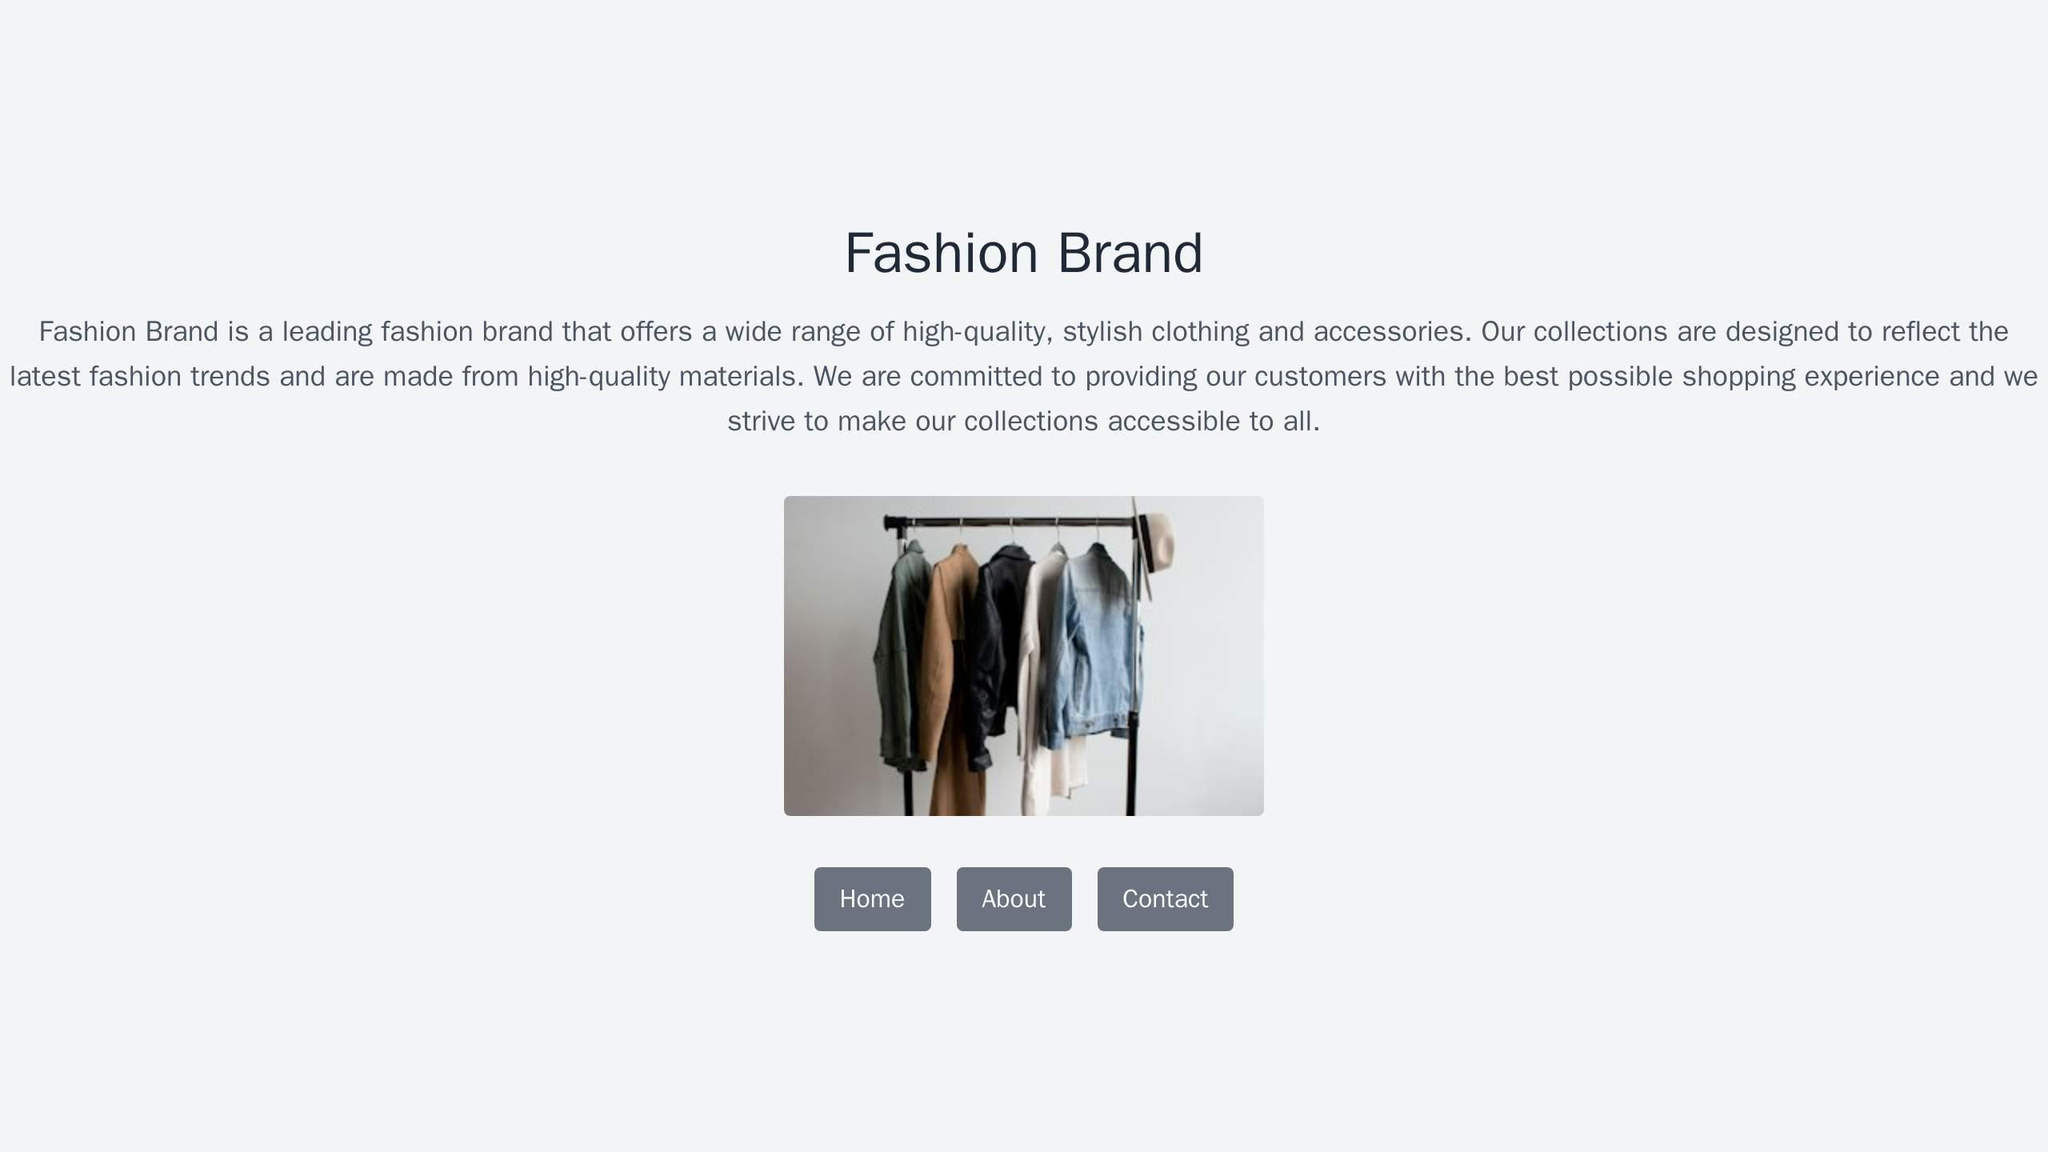\nYou are an expert Tailwind developer\nYou take screenshots of a reference web page from the user, and then build a single page apps\nusing Tailwind, HTML and JS.\n\n- Make sure the app looks exactly like the screenshot.\n- Pay close attention to background color, text color, font size, font family, \npadding, margin, border, etc. Match the colors and sizes exactly.\n- Use the exact text from the screenshot.\n- Do not add comments in the code such as \"<!-- Add other navigation links as needed -->\" and \"<!-- ... other news items ... -->\" in place of writing the full code. WRITE THE FULL CODE.\n- Repeat elements as needed to match the screenshot. For example, if there are 15 items, the code should have 15 items. DO NOT LEAVE comments like \"<!-- Repeat for each news item -->\" or bad things will happen.\n- For images, use placeholder images from https://placehold.co and include a detailed description of the image in the alt text so that an image generation AI can generate the image later.\n\nIn terms of libraries,\n\n- Use this script to include Tailwind: <script src=\"https://cdn.tailwindcss.com\"></script>\n\nReturn only the full code in <html></html> tags.\nDo not include markdown \"```\" or \"```html\" at the start or end.\n <html>
  <head>
    <title>Fashion Brand</title>
    <script src="https://cdn.tailwindcss.com"></script>
  </head>
  <body class="bg-gray-200">
    <div class="container mx-auto px-4">
      <h1 class="text-3xl font-bold text-gray-700 text-center mt-10">
        Fashion Brand
      </h1>
      <p class="text-gray-500 text-center mt-4">
        Fashion Brand is a leading fashion brand that offers a wide
        range of high-quality, stylish clothing and accessories. Our
        collections are designed to reflect the latest fashion trends
        and are made from high-quality materials. We are committed to
        providing our customers with the best possible shopping
        experience and we strive to make our collections accessible to
        all.
      </p>
      <div class="flex justify-center mt-10">
        <img
          src="https://placehold.co/600x400.png"
          alt="A rack of clothes with a hat on top"
          class="rounded-lg shadow-md"
        />
      </div>
      <div class="flex justify-center mt-10 gap-4">
        <button
          class="bg-gray-400 hover:bg-gray-500 text-white font-bold py-2 px-4 rounded"
        >
          Home
        </button>
        <button
          class="bg-gray-400 hover:bg-gray-500 text-white font-bold py-2 px-4 rounded"
        >
          About
        </button>
        <button
          class="bg-gray-400 hover:bg-gray-500 text-white font-bold py-2 px-4 rounded"
        >
          Contact
        </button>
      </div>
    </div>
  </body>
</html> 